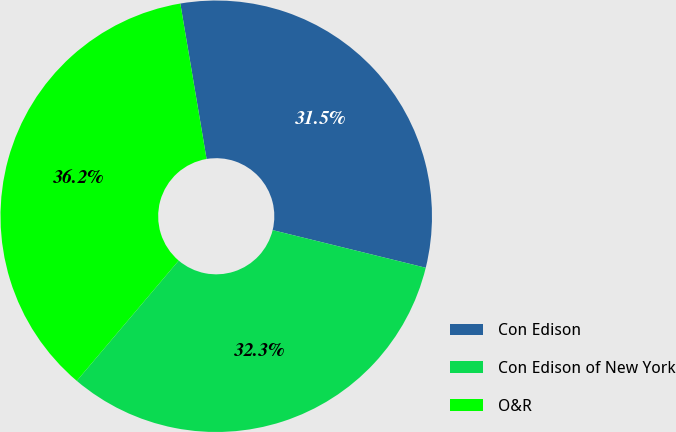<chart> <loc_0><loc_0><loc_500><loc_500><pie_chart><fcel>Con Edison<fcel>Con Edison of New York<fcel>O&R<nl><fcel>31.5%<fcel>32.35%<fcel>36.15%<nl></chart> 